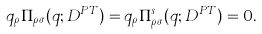<formula> <loc_0><loc_0><loc_500><loc_500>q _ { \rho } \Pi _ { \rho \sigma } ( q ; D ^ { P T } ) = q _ { \rho } \Pi ^ { s } _ { \rho \sigma } ( q ; D ^ { P T } ) = 0 .</formula> 